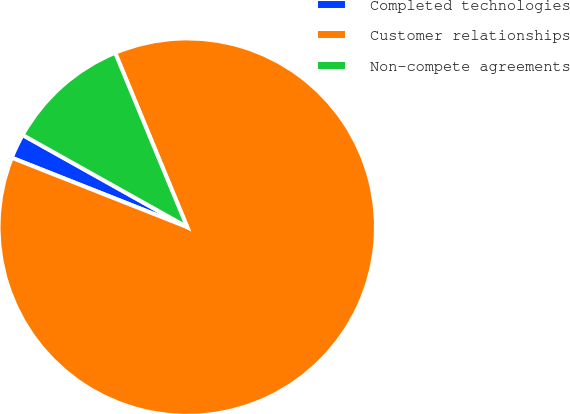<chart> <loc_0><loc_0><loc_500><loc_500><pie_chart><fcel>Completed technologies<fcel>Customer relationships<fcel>Non-compete agreements<nl><fcel>2.13%<fcel>87.23%<fcel>10.64%<nl></chart> 